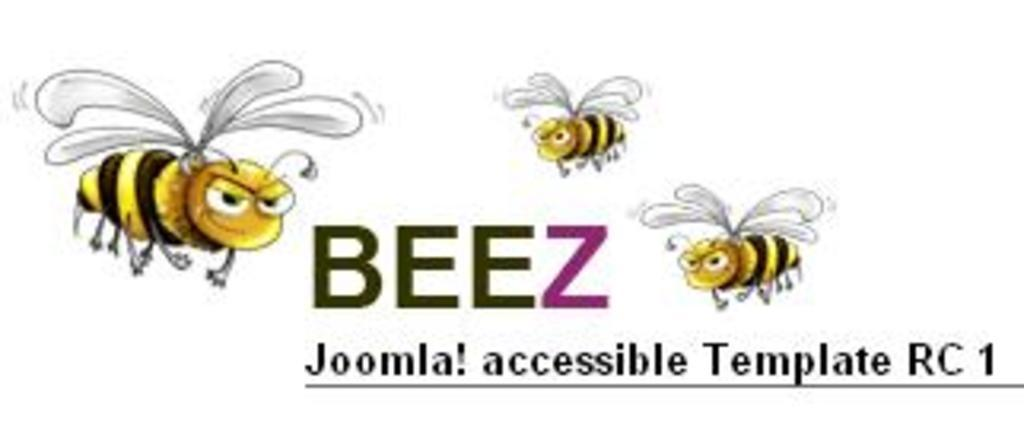What type of image is being described? The image is animated. What creatures are present in the animated image? There are honey bees in the image. Is there any text present in the image? Yes, there is text written in the image. How many pets can be seen in the image? There are no pets present in the image; it features honey bees and text. What type of women are depicted in the image? There are no women depicted in the image; it features honey bees and text. 